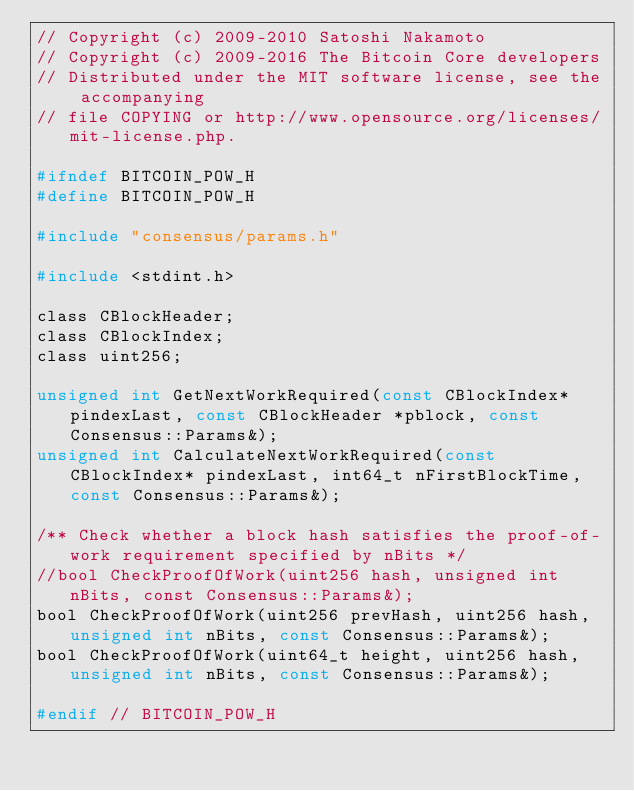<code> <loc_0><loc_0><loc_500><loc_500><_C_>// Copyright (c) 2009-2010 Satoshi Nakamoto
// Copyright (c) 2009-2016 The Bitcoin Core developers
// Distributed under the MIT software license, see the accompanying
// file COPYING or http://www.opensource.org/licenses/mit-license.php.

#ifndef BITCOIN_POW_H
#define BITCOIN_POW_H

#include "consensus/params.h"

#include <stdint.h>

class CBlockHeader;
class CBlockIndex;
class uint256;

unsigned int GetNextWorkRequired(const CBlockIndex* pindexLast, const CBlockHeader *pblock, const Consensus::Params&);
unsigned int CalculateNextWorkRequired(const CBlockIndex* pindexLast, int64_t nFirstBlockTime, const Consensus::Params&);

/** Check whether a block hash satisfies the proof-of-work requirement specified by nBits */
//bool CheckProofOfWork(uint256 hash, unsigned int nBits, const Consensus::Params&);
bool CheckProofOfWork(uint256 prevHash, uint256 hash, unsigned int nBits, const Consensus::Params&);
bool CheckProofOfWork(uint64_t height, uint256 hash, unsigned int nBits, const Consensus::Params&);

#endif // BITCOIN_POW_H
</code> 